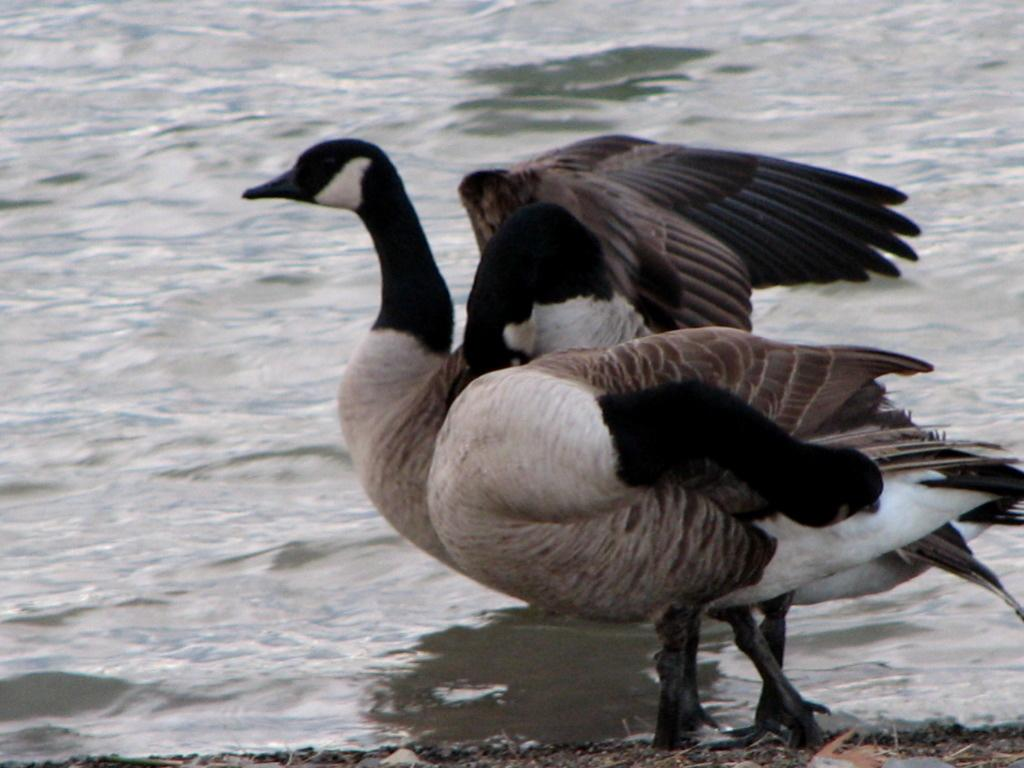What animals are in the center of the image? There are two birds in the center of the image. What body of water is at the bottom of the image? There is a river at the bottom of the image. What type of waste or debris is visible in the image? There is some scrap visible in the image. Where is the girl walking along the sidewalk in the image? There is no girl or sidewalk present in the image. What type of rock can be seen in the image? There is no rock present in the image. 